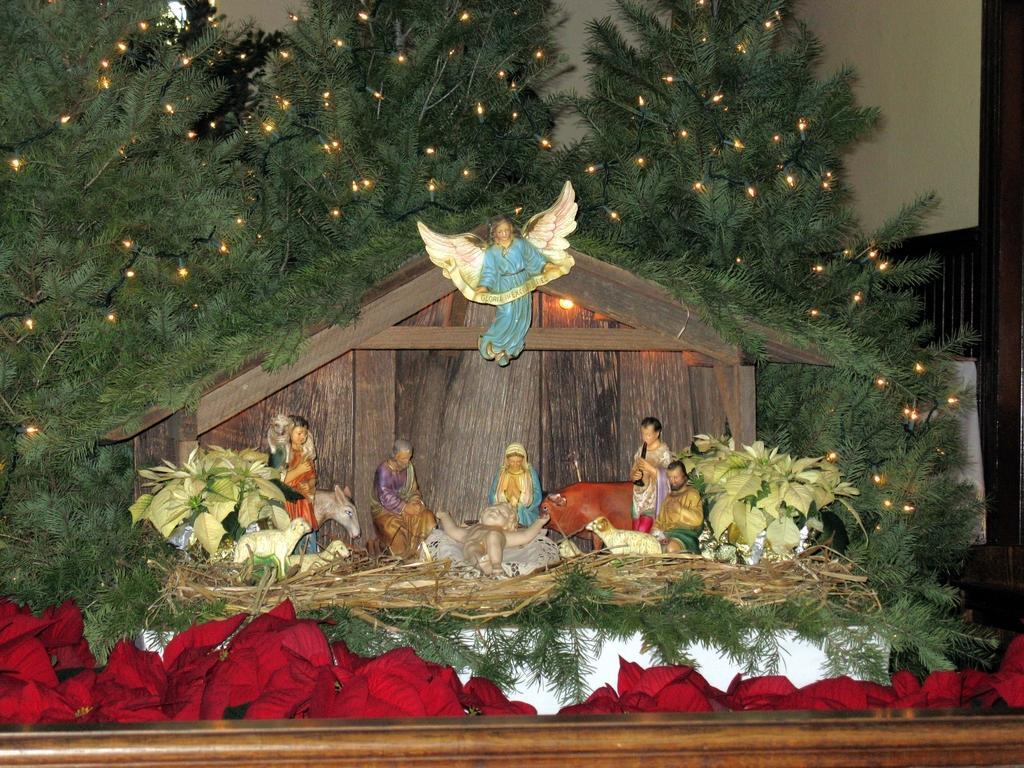Can you describe this image briefly? In the foreground of this image, there are many toys, plants, trees with lights near a hut. On bottom, there are red colored flowers. In the background, there is a wall. 